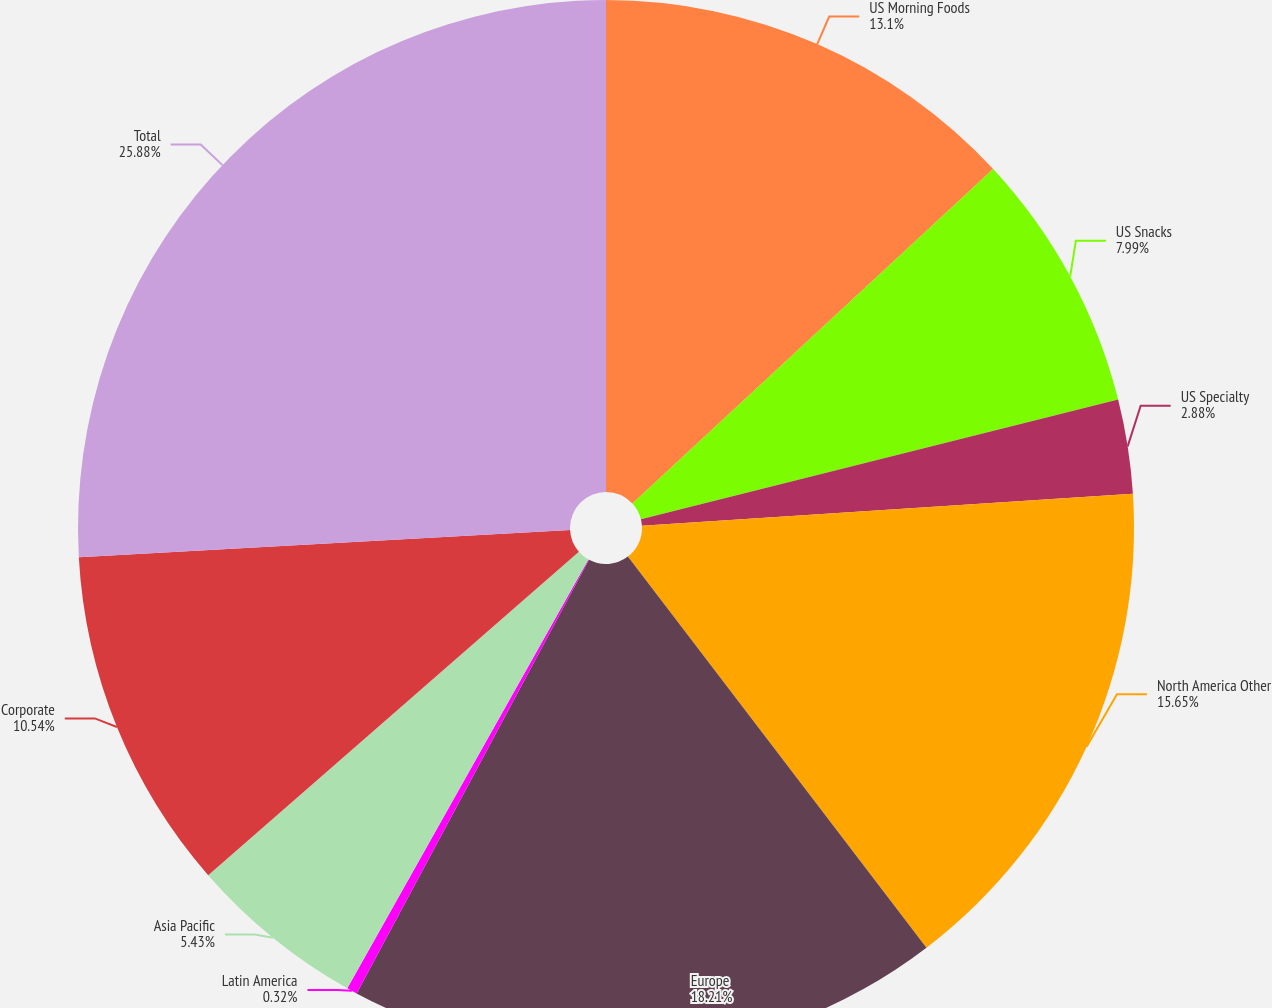Convert chart. <chart><loc_0><loc_0><loc_500><loc_500><pie_chart><fcel>US Morning Foods<fcel>US Snacks<fcel>US Specialty<fcel>North America Other<fcel>Europe<fcel>Latin America<fcel>Asia Pacific<fcel>Corporate<fcel>Total<nl><fcel>13.1%<fcel>7.99%<fcel>2.88%<fcel>15.65%<fcel>18.21%<fcel>0.32%<fcel>5.43%<fcel>10.54%<fcel>25.88%<nl></chart> 